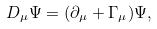Convert formula to latex. <formula><loc_0><loc_0><loc_500><loc_500>D _ { \mu } \Psi = ( \partial _ { \mu } + \Gamma _ { \mu } ) \Psi ,</formula> 